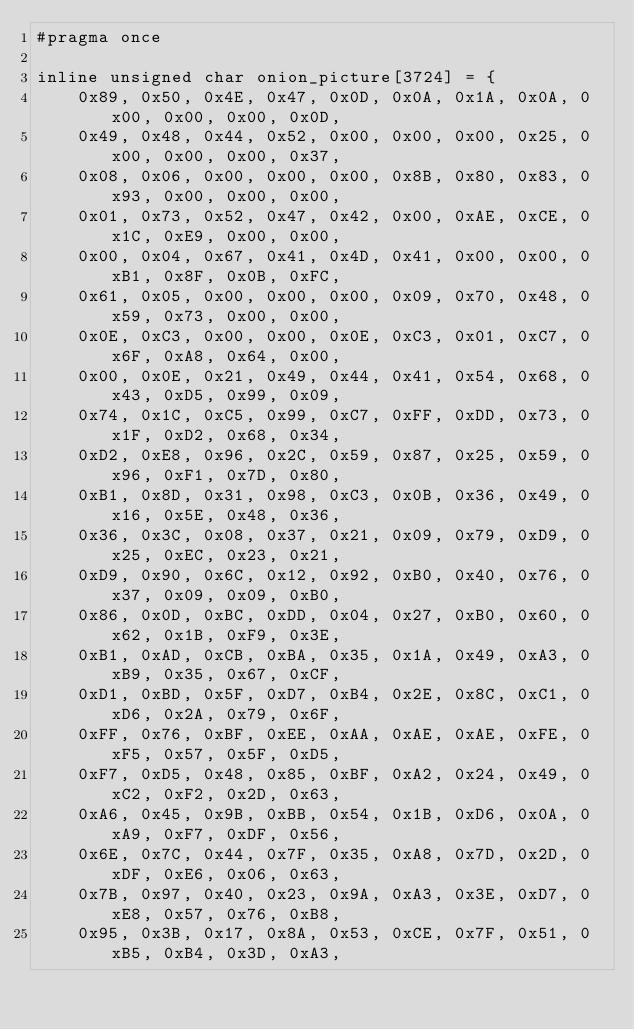<code> <loc_0><loc_0><loc_500><loc_500><_C_>#pragma once

inline unsigned char onion_picture[3724] = {
	0x89, 0x50, 0x4E, 0x47, 0x0D, 0x0A, 0x1A, 0x0A, 0x00, 0x00, 0x00, 0x0D,
	0x49, 0x48, 0x44, 0x52, 0x00, 0x00, 0x00, 0x25, 0x00, 0x00, 0x00, 0x37,
	0x08, 0x06, 0x00, 0x00, 0x00, 0x8B, 0x80, 0x83, 0x93, 0x00, 0x00, 0x00,
	0x01, 0x73, 0x52, 0x47, 0x42, 0x00, 0xAE, 0xCE, 0x1C, 0xE9, 0x00, 0x00,
	0x00, 0x04, 0x67, 0x41, 0x4D, 0x41, 0x00, 0x00, 0xB1, 0x8F, 0x0B, 0xFC,
	0x61, 0x05, 0x00, 0x00, 0x00, 0x09, 0x70, 0x48, 0x59, 0x73, 0x00, 0x00,
	0x0E, 0xC3, 0x00, 0x00, 0x0E, 0xC3, 0x01, 0xC7, 0x6F, 0xA8, 0x64, 0x00,
	0x00, 0x0E, 0x21, 0x49, 0x44, 0x41, 0x54, 0x68, 0x43, 0xD5, 0x99, 0x09,
	0x74, 0x1C, 0xC5, 0x99, 0xC7, 0xFF, 0xDD, 0x73, 0x1F, 0xD2, 0x68, 0x34,
	0xD2, 0xE8, 0x96, 0x2C, 0x59, 0x87, 0x25, 0x59, 0x96, 0xF1, 0x7D, 0x80,
	0xB1, 0x8D, 0x31, 0x98, 0xC3, 0x0B, 0x36, 0x49, 0x16, 0x5E, 0x48, 0x36,
	0x36, 0x3C, 0x08, 0x37, 0x21, 0x09, 0x79, 0xD9, 0x25, 0xEC, 0x23, 0x21,
	0xD9, 0x90, 0x6C, 0x12, 0x92, 0xB0, 0x40, 0x76, 0x37, 0x09, 0x09, 0xB0,
	0x86, 0x0D, 0xBC, 0xDD, 0x04, 0x27, 0xB0, 0x60, 0x62, 0x1B, 0xF9, 0x3E,
	0xB1, 0xAD, 0xCB, 0xBA, 0x35, 0x1A, 0x49, 0xA3, 0xB9, 0x35, 0x67, 0xCF,
	0xD1, 0xBD, 0x5F, 0xD7, 0xB4, 0x2E, 0x8C, 0xC1, 0xD6, 0x2A, 0x79, 0x6F,
	0xFF, 0x76, 0xBF, 0xEE, 0xAA, 0xAE, 0xAE, 0xFE, 0xF5, 0x57, 0x5F, 0xD5,
	0xF7, 0xD5, 0x48, 0x85, 0xBF, 0xA2, 0x24, 0x49, 0xC2, 0xF2, 0x2D, 0x63,
	0xA6, 0x45, 0x9B, 0xBB, 0x54, 0x1B, 0xD6, 0x0A, 0xA9, 0xF7, 0xDF, 0x56,
	0x6E, 0x7C, 0x44, 0x7F, 0x35, 0xA8, 0x7D, 0x2D, 0xDF, 0xE6, 0x06, 0x63,
	0x7B, 0x97, 0x40, 0x23, 0x9A, 0xA3, 0x3E, 0xD7, 0xE8, 0x57, 0x76, 0xB8,
	0x95, 0x3B, 0x17, 0x8A, 0x53, 0xCE, 0x7F, 0x51, 0xB5, 0xB4, 0x3D, 0xA3,</code> 